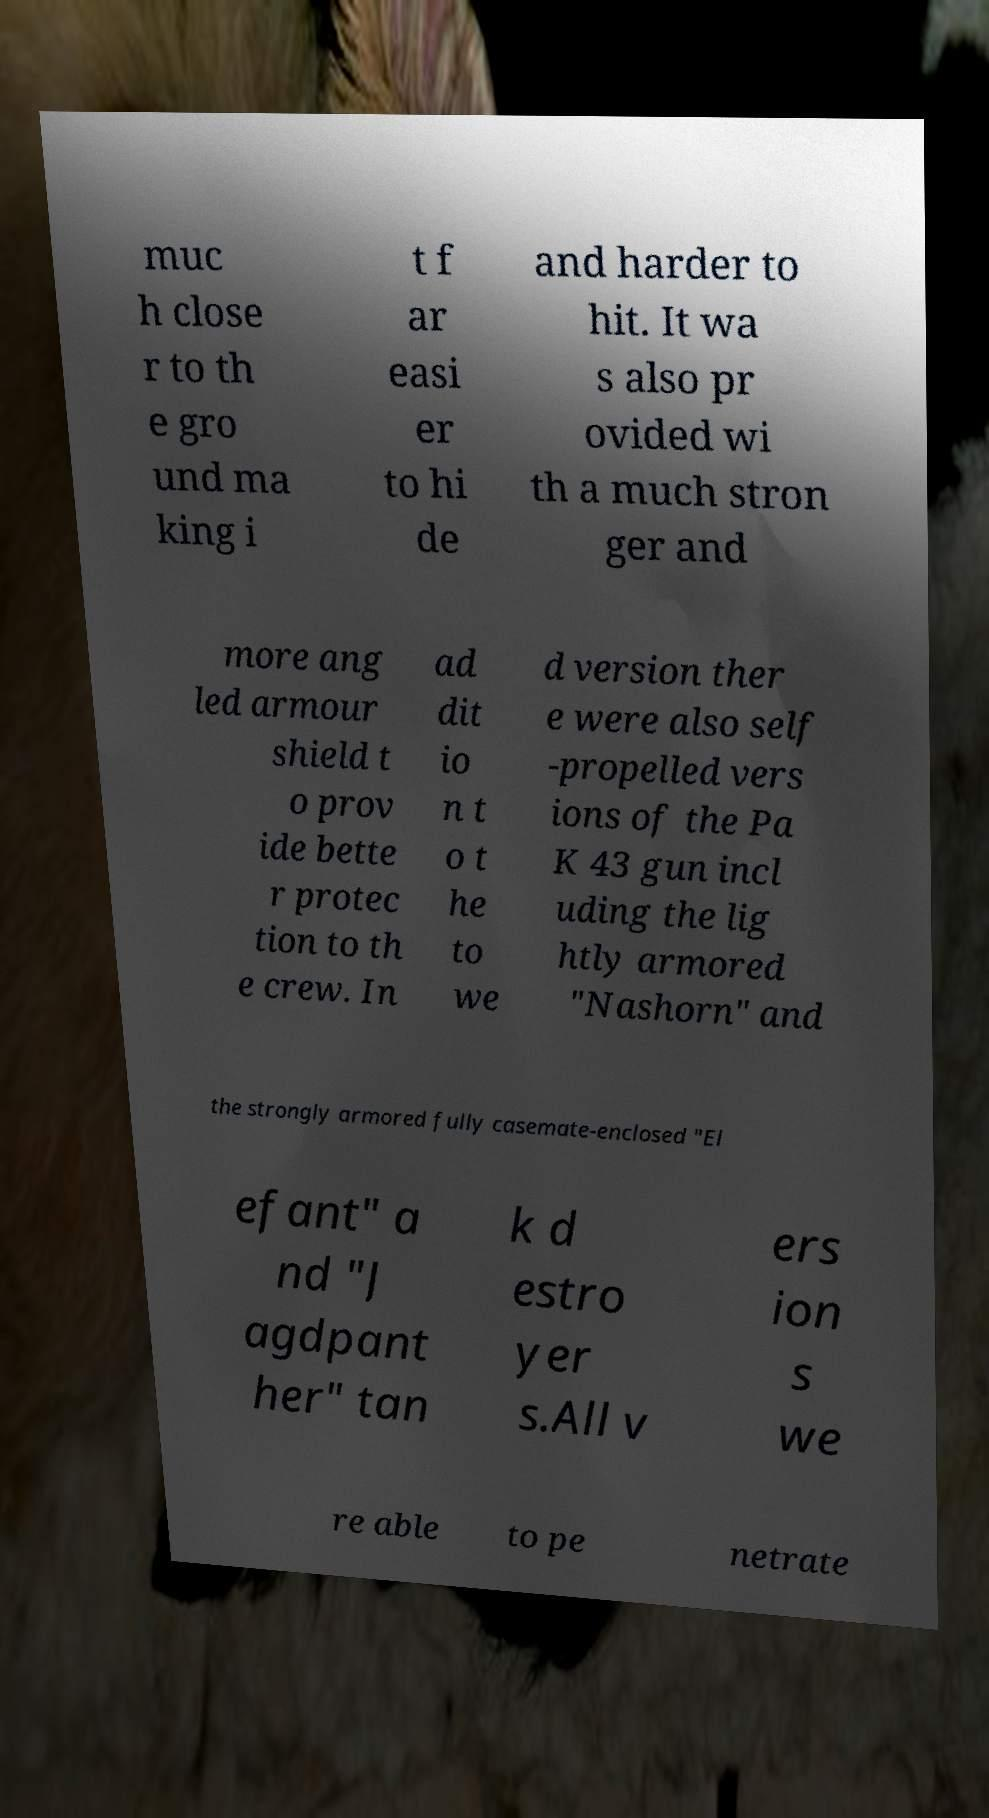Please identify and transcribe the text found in this image. muc h close r to th e gro und ma king i t f ar easi er to hi de and harder to hit. It wa s also pr ovided wi th a much stron ger and more ang led armour shield t o prov ide bette r protec tion to th e crew. In ad dit io n t o t he to we d version ther e were also self -propelled vers ions of the Pa K 43 gun incl uding the lig htly armored "Nashorn" and the strongly armored fully casemate-enclosed "El efant" a nd "J agdpant her" tan k d estro yer s.All v ers ion s we re able to pe netrate 